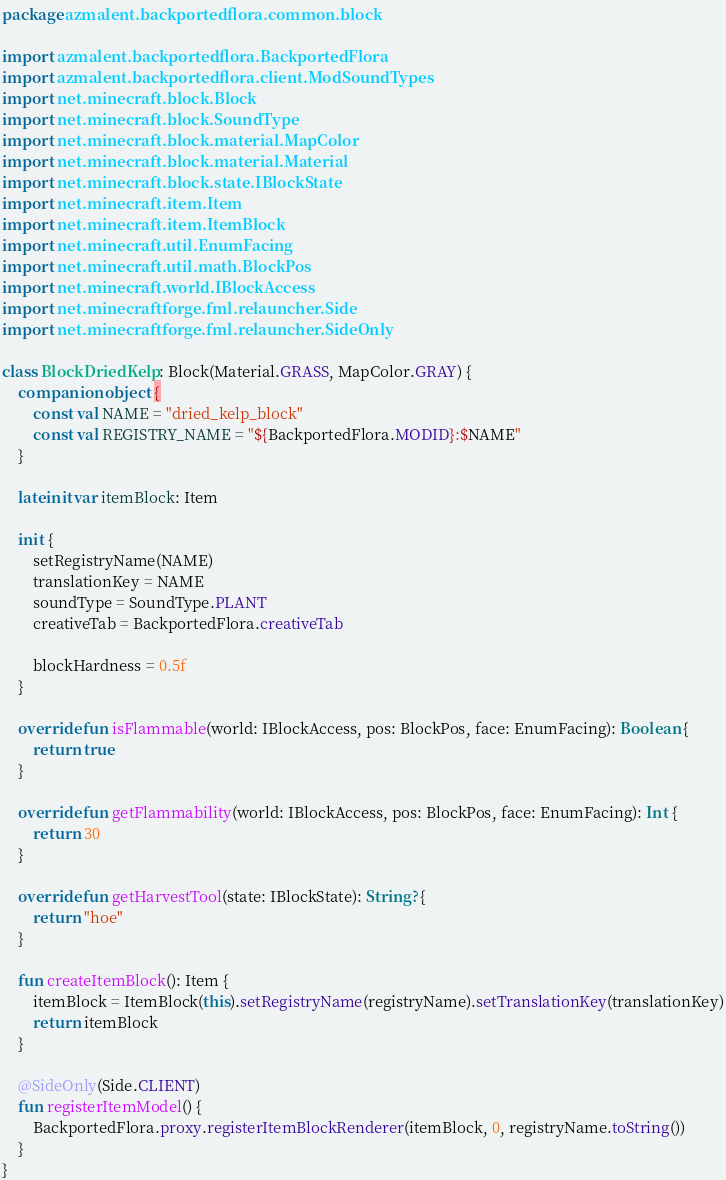<code> <loc_0><loc_0><loc_500><loc_500><_Kotlin_>package azmalent.backportedflora.common.block

import azmalent.backportedflora.BackportedFlora
import azmalent.backportedflora.client.ModSoundTypes
import net.minecraft.block.Block
import net.minecraft.block.SoundType
import net.minecraft.block.material.MapColor
import net.minecraft.block.material.Material
import net.minecraft.block.state.IBlockState
import net.minecraft.item.Item
import net.minecraft.item.ItemBlock
import net.minecraft.util.EnumFacing
import net.minecraft.util.math.BlockPos
import net.minecraft.world.IBlockAccess
import net.minecraftforge.fml.relauncher.Side
import net.minecraftforge.fml.relauncher.SideOnly

class BlockDriedKelp : Block(Material.GRASS, MapColor.GRAY) {
    companion object {
        const val NAME = "dried_kelp_block"
        const val REGISTRY_NAME = "${BackportedFlora.MODID}:$NAME"
    }

    lateinit var itemBlock: Item

    init {
        setRegistryName(NAME)
        translationKey = NAME
        soundType = SoundType.PLANT
        creativeTab = BackportedFlora.creativeTab

        blockHardness = 0.5f
    }

    override fun isFlammable(world: IBlockAccess, pos: BlockPos, face: EnumFacing): Boolean {
        return true
    }

    override fun getFlammability(world: IBlockAccess, pos: BlockPos, face: EnumFacing): Int {
        return 30
    }

    override fun getHarvestTool(state: IBlockState): String? {
        return "hoe"
    }

    fun createItemBlock(): Item {
        itemBlock = ItemBlock(this).setRegistryName(registryName).setTranslationKey(translationKey)
        return itemBlock
    }

    @SideOnly(Side.CLIENT)
    fun registerItemModel() {
        BackportedFlora.proxy.registerItemBlockRenderer(itemBlock, 0, registryName.toString())
    }
}</code> 